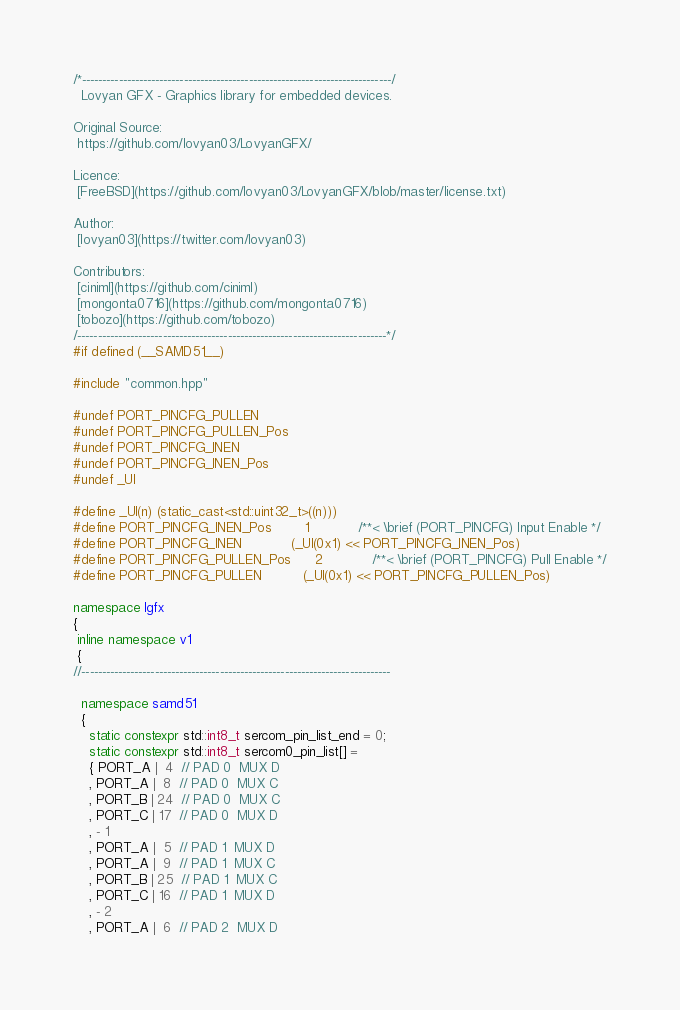<code> <loc_0><loc_0><loc_500><loc_500><_C++_>/*----------------------------------------------------------------------------/
  Lovyan GFX - Graphics library for embedded devices.

Original Source:
 https://github.com/lovyan03/LovyanGFX/

Licence:
 [FreeBSD](https://github.com/lovyan03/LovyanGFX/blob/master/license.txt)

Author:
 [lovyan03](https://twitter.com/lovyan03)

Contributors:
 [ciniml](https://github.com/ciniml)
 [mongonta0716](https://github.com/mongonta0716)
 [tobozo](https://github.com/tobozo)
/----------------------------------------------------------------------------*/
#if defined (__SAMD51__)

#include "common.hpp"

#undef PORT_PINCFG_PULLEN
#undef PORT_PINCFG_PULLEN_Pos
#undef PORT_PINCFG_INEN
#undef PORT_PINCFG_INEN_Pos
#undef _Ul

#define _Ul(n) (static_cast<std::uint32_t>((n)))
#define PORT_PINCFG_INEN_Pos        1            /**< \brief (PORT_PINCFG) Input Enable */
#define PORT_PINCFG_INEN            (_Ul(0x1) << PORT_PINCFG_INEN_Pos)
#define PORT_PINCFG_PULLEN_Pos      2            /**< \brief (PORT_PINCFG) Pull Enable */
#define PORT_PINCFG_PULLEN          (_Ul(0x1) << PORT_PINCFG_PULLEN_Pos)

namespace lgfx
{
 inline namespace v1
 {
//----------------------------------------------------------------------------

  namespace samd51
  {
    static constexpr std::int8_t sercom_pin_list_end = 0;
    static constexpr std::int8_t sercom0_pin_list[] =
    { PORT_A |  4  // PAD 0  MUX D
    , PORT_A |  8  // PAD 0  MUX C
    , PORT_B | 24  // PAD 0  MUX C
    , PORT_C | 17  // PAD 0  MUX D
    , - 1
    , PORT_A |  5  // PAD 1  MUX D
    , PORT_A |  9  // PAD 1  MUX C
    , PORT_B | 25  // PAD 1  MUX C
    , PORT_C | 16  // PAD 1  MUX D
    , - 2
    , PORT_A |  6  // PAD 2  MUX D</code> 